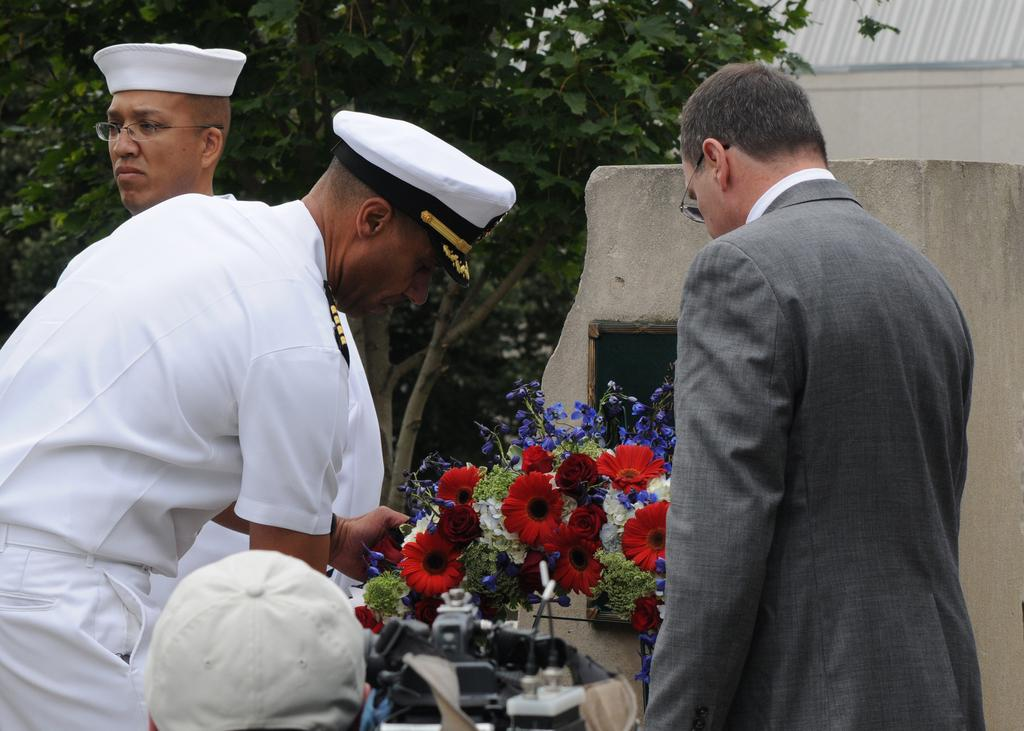How many people are present in the image? There are persons in the image, but the exact number cannot be determined from the provided facts. What type of plants can be seen in the image? There are plants with flowers in the image. What object in the image might be used for a specific purpose? There is a device in the image, but its purpose cannot be determined from the provided facts. Can you describe the attire of one of the persons in the image? A person is wearing a cap in the image. What can be seen in the background of the image? There are walls and trees in the background of the image. What type of competition is taking place in the image? There is no indication of a competition in the image; it features persons, plants with flowers, a device, a person wearing a cap, walls, and trees in the background. 